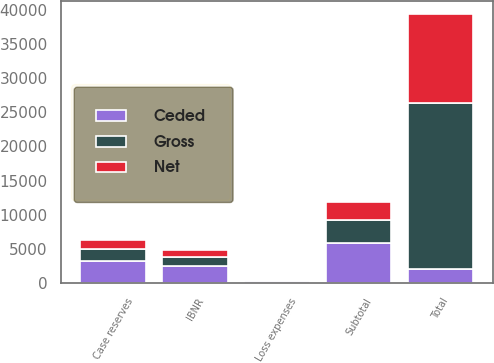Convert chart. <chart><loc_0><loc_0><loc_500><loc_500><stacked_bar_chart><ecel><fcel>Case reserves<fcel>Loss expenses<fcel>IBNR<fcel>Subtotal<fcel>Total<nl><fcel>Ceded<fcel>3180<fcel>264<fcel>2456<fcel>5900<fcel>2134.5<nl><fcel>Net<fcel>1367<fcel>92<fcel>1084<fcel>2543<fcel>12935<nl><fcel>Gross<fcel>1813<fcel>172<fcel>1372<fcel>3357<fcel>24241<nl></chart> 